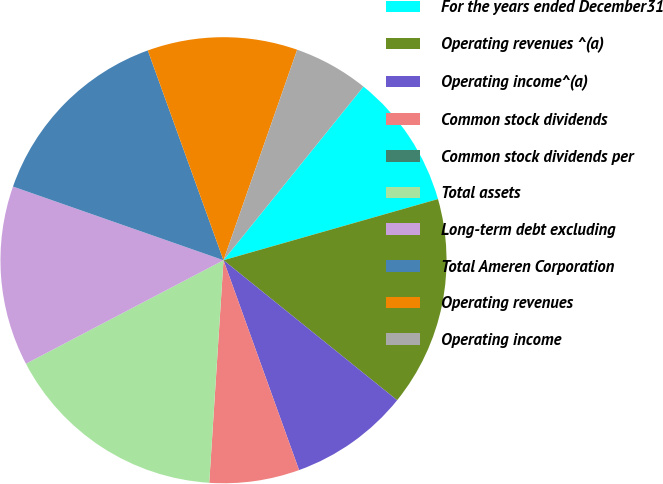Convert chart to OTSL. <chart><loc_0><loc_0><loc_500><loc_500><pie_chart><fcel>For the years ended December31<fcel>Operating revenues ^(a)<fcel>Operating income^(a)<fcel>Common stock dividends<fcel>Common stock dividends per<fcel>Total assets<fcel>Long-term debt excluding<fcel>Total Ameren Corporation<fcel>Operating revenues<fcel>Operating income<nl><fcel>9.78%<fcel>15.22%<fcel>8.7%<fcel>6.52%<fcel>0.0%<fcel>16.3%<fcel>13.04%<fcel>14.13%<fcel>10.87%<fcel>5.44%<nl></chart> 